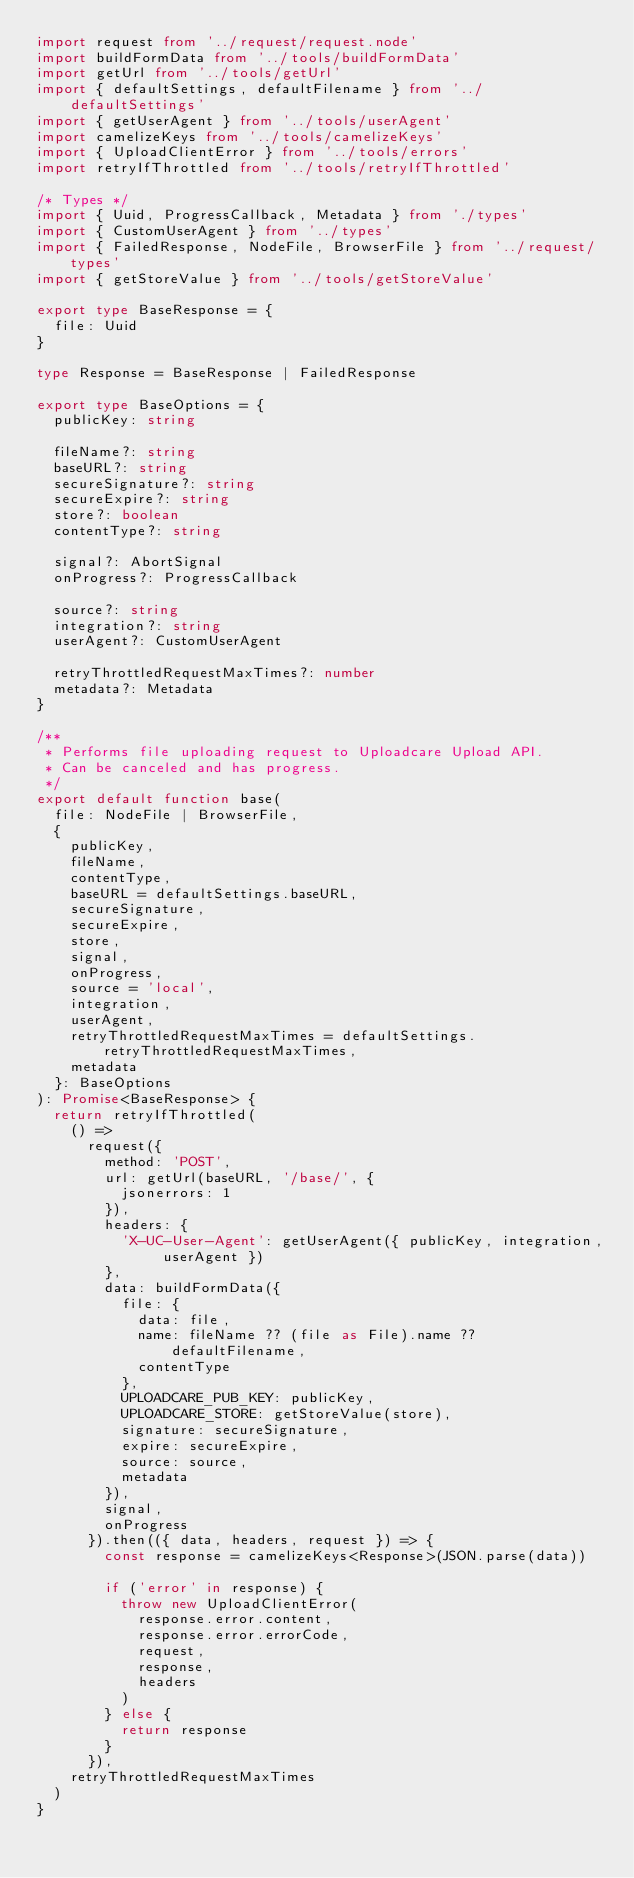<code> <loc_0><loc_0><loc_500><loc_500><_TypeScript_>import request from '../request/request.node'
import buildFormData from '../tools/buildFormData'
import getUrl from '../tools/getUrl'
import { defaultSettings, defaultFilename } from '../defaultSettings'
import { getUserAgent } from '../tools/userAgent'
import camelizeKeys from '../tools/camelizeKeys'
import { UploadClientError } from '../tools/errors'
import retryIfThrottled from '../tools/retryIfThrottled'

/* Types */
import { Uuid, ProgressCallback, Metadata } from './types'
import { CustomUserAgent } from '../types'
import { FailedResponse, NodeFile, BrowserFile } from '../request/types'
import { getStoreValue } from '../tools/getStoreValue'

export type BaseResponse = {
  file: Uuid
}

type Response = BaseResponse | FailedResponse

export type BaseOptions = {
  publicKey: string

  fileName?: string
  baseURL?: string
  secureSignature?: string
  secureExpire?: string
  store?: boolean
  contentType?: string

  signal?: AbortSignal
  onProgress?: ProgressCallback

  source?: string
  integration?: string
  userAgent?: CustomUserAgent

  retryThrottledRequestMaxTimes?: number
  metadata?: Metadata
}

/**
 * Performs file uploading request to Uploadcare Upload API.
 * Can be canceled and has progress.
 */
export default function base(
  file: NodeFile | BrowserFile,
  {
    publicKey,
    fileName,
    contentType,
    baseURL = defaultSettings.baseURL,
    secureSignature,
    secureExpire,
    store,
    signal,
    onProgress,
    source = 'local',
    integration,
    userAgent,
    retryThrottledRequestMaxTimes = defaultSettings.retryThrottledRequestMaxTimes,
    metadata
  }: BaseOptions
): Promise<BaseResponse> {
  return retryIfThrottled(
    () =>
      request({
        method: 'POST',
        url: getUrl(baseURL, '/base/', {
          jsonerrors: 1
        }),
        headers: {
          'X-UC-User-Agent': getUserAgent({ publicKey, integration, userAgent })
        },
        data: buildFormData({
          file: {
            data: file,
            name: fileName ?? (file as File).name ?? defaultFilename,
            contentType
          },
          UPLOADCARE_PUB_KEY: publicKey,
          UPLOADCARE_STORE: getStoreValue(store),
          signature: secureSignature,
          expire: secureExpire,
          source: source,
          metadata
        }),
        signal,
        onProgress
      }).then(({ data, headers, request }) => {
        const response = camelizeKeys<Response>(JSON.parse(data))

        if ('error' in response) {
          throw new UploadClientError(
            response.error.content,
            response.error.errorCode,
            request,
            response,
            headers
          )
        } else {
          return response
        }
      }),
    retryThrottledRequestMaxTimes
  )
}
</code> 